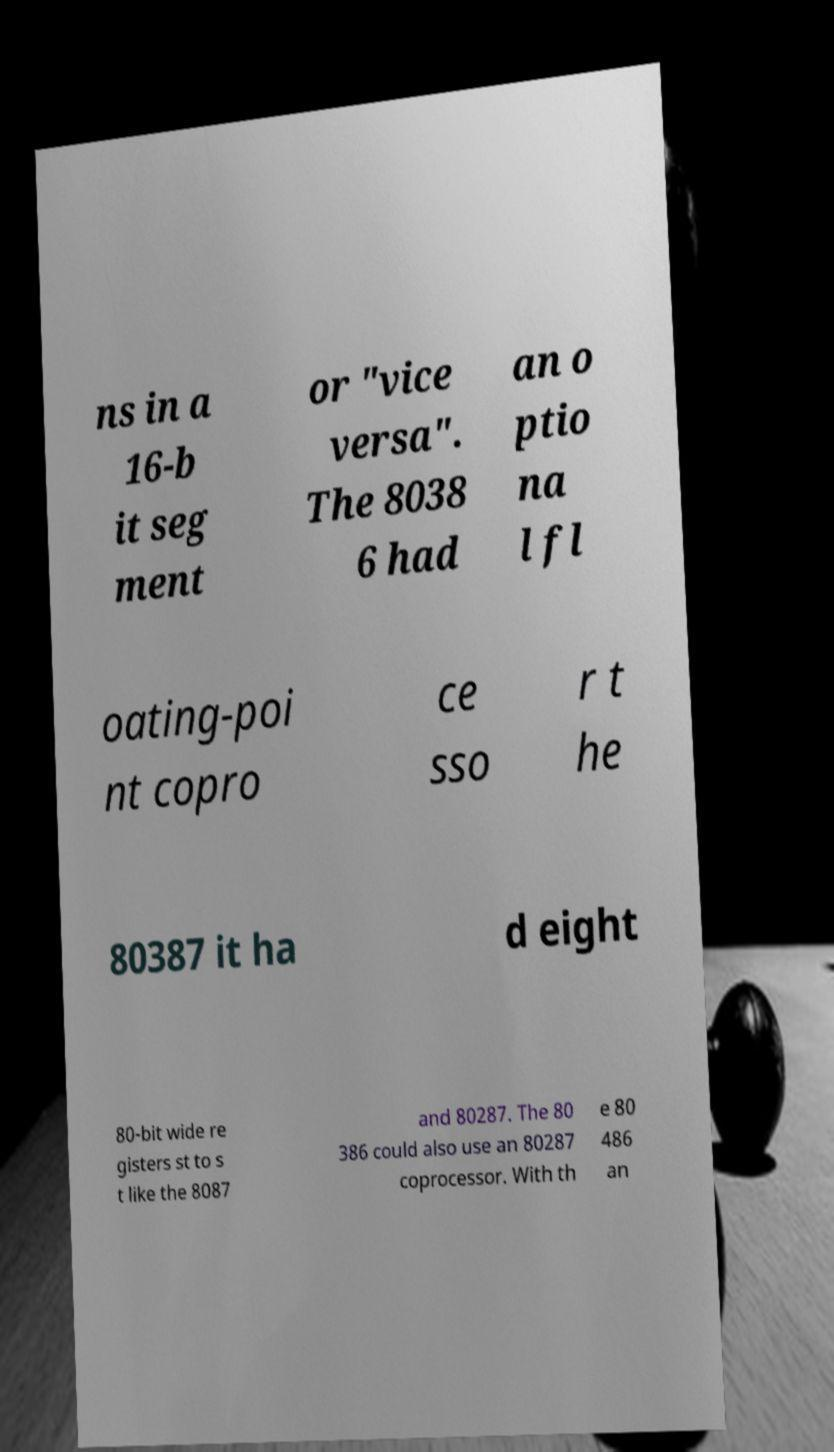There's text embedded in this image that I need extracted. Can you transcribe it verbatim? ns in a 16-b it seg ment or "vice versa". The 8038 6 had an o ptio na l fl oating-poi nt copro ce sso r t he 80387 it ha d eight 80-bit wide re gisters st to s t like the 8087 and 80287. The 80 386 could also use an 80287 coprocessor. With th e 80 486 an 